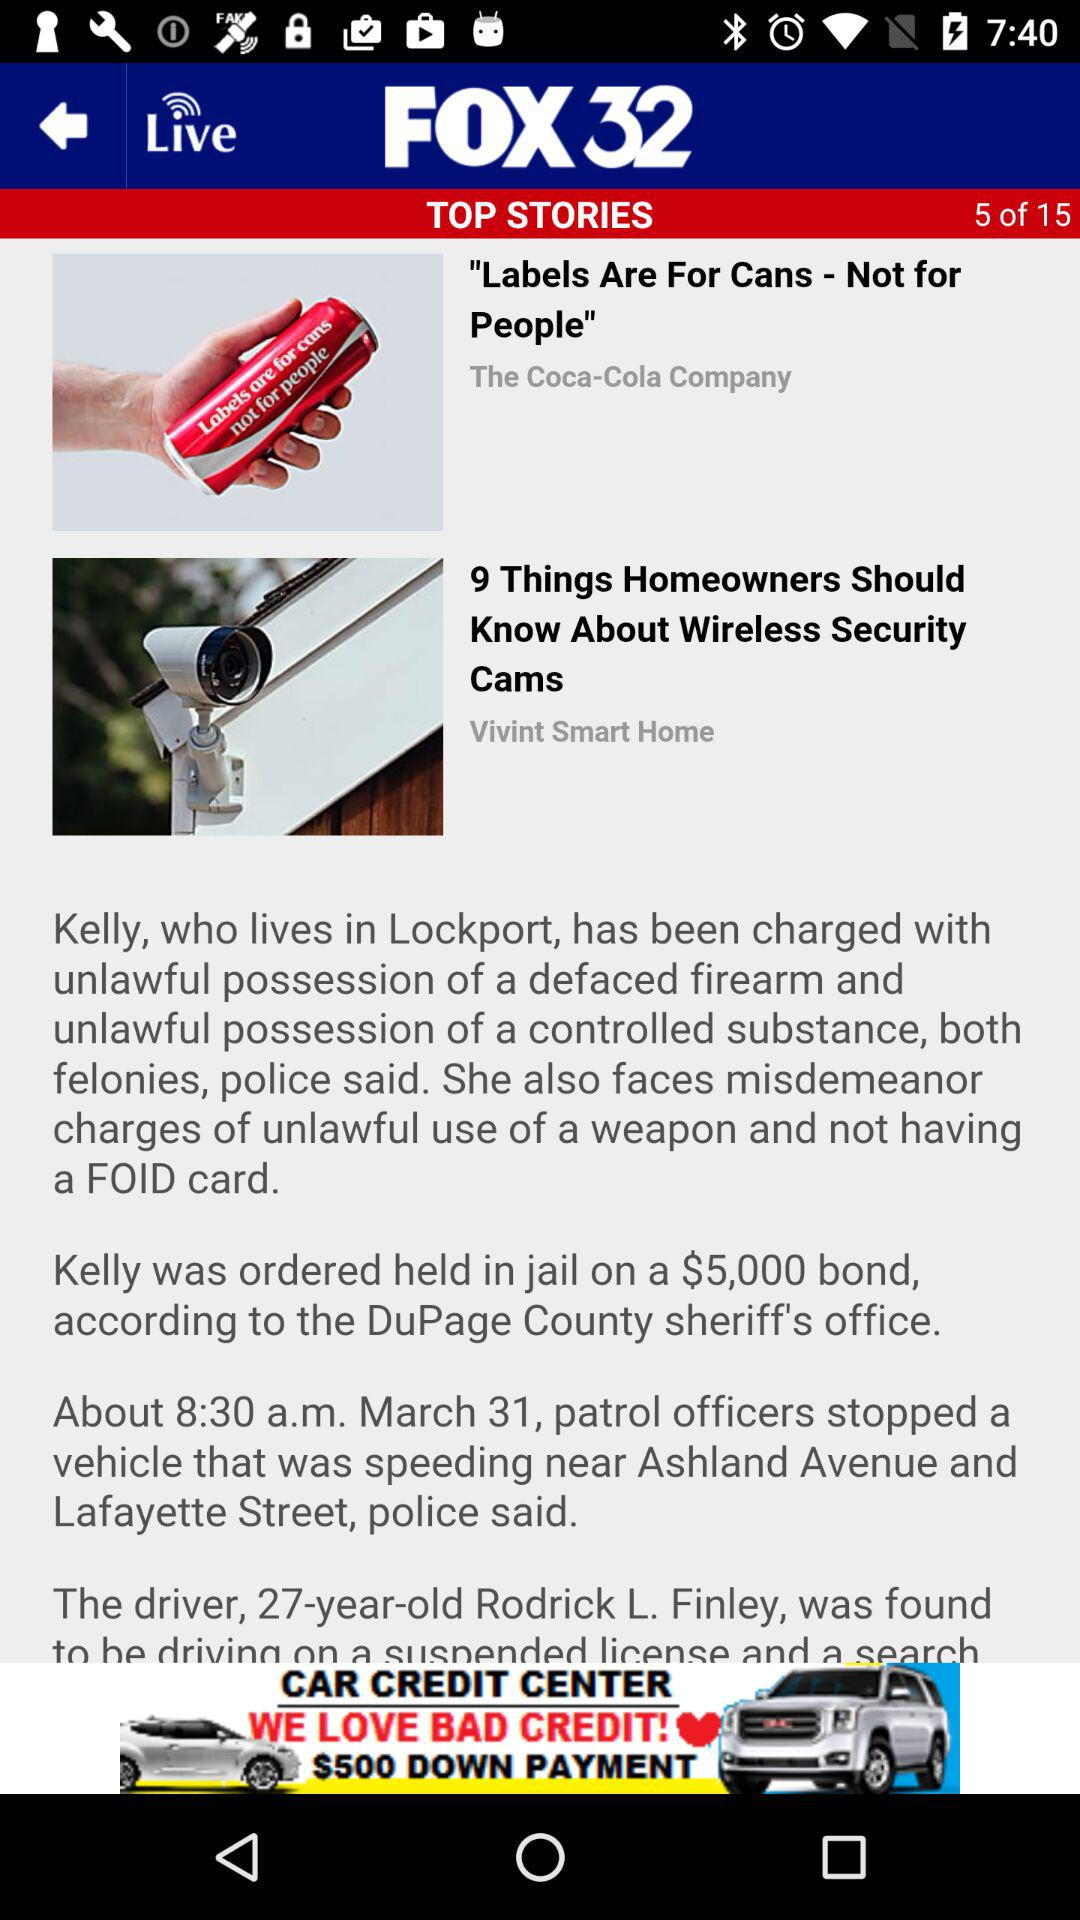What is the total number of top stories? There are 15 top stories in total. 